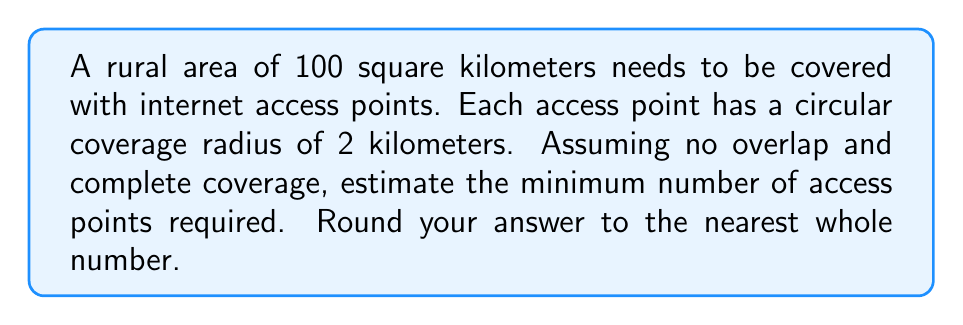Can you answer this question? To solve this problem, we'll follow these steps:

1) The area covered by each access point:
   Each access point covers a circular area. The area of a circle is given by $A = \pi r^2$.
   $$A = \pi (2\text{ km})^2 = 4\pi \text{ km}^2$$

2) The total area to be covered:
   The rural area is 100 square kilometers.

3) The number of access points needed:
   We can estimate this by dividing the total area by the area covered by each access point.
   $$\text{Number of access points} = \frac{\text{Total area}}{\text{Area per access point}}$$
   $$= \frac{100 \text{ km}^2}{4\pi \text{ km}^2} \approx 7.9577$$

4) Rounding to the nearest whole number:
   Since we can't have a fractional number of access points, and we need complete coverage, we round up to 8.

Note: This calculation assumes perfect circular coverage and no overlap, which is idealistic. In practice, more access points might be needed due to terrain, obstacles, and the need for some overlap to ensure continuous coverage.
Answer: 8 access points 